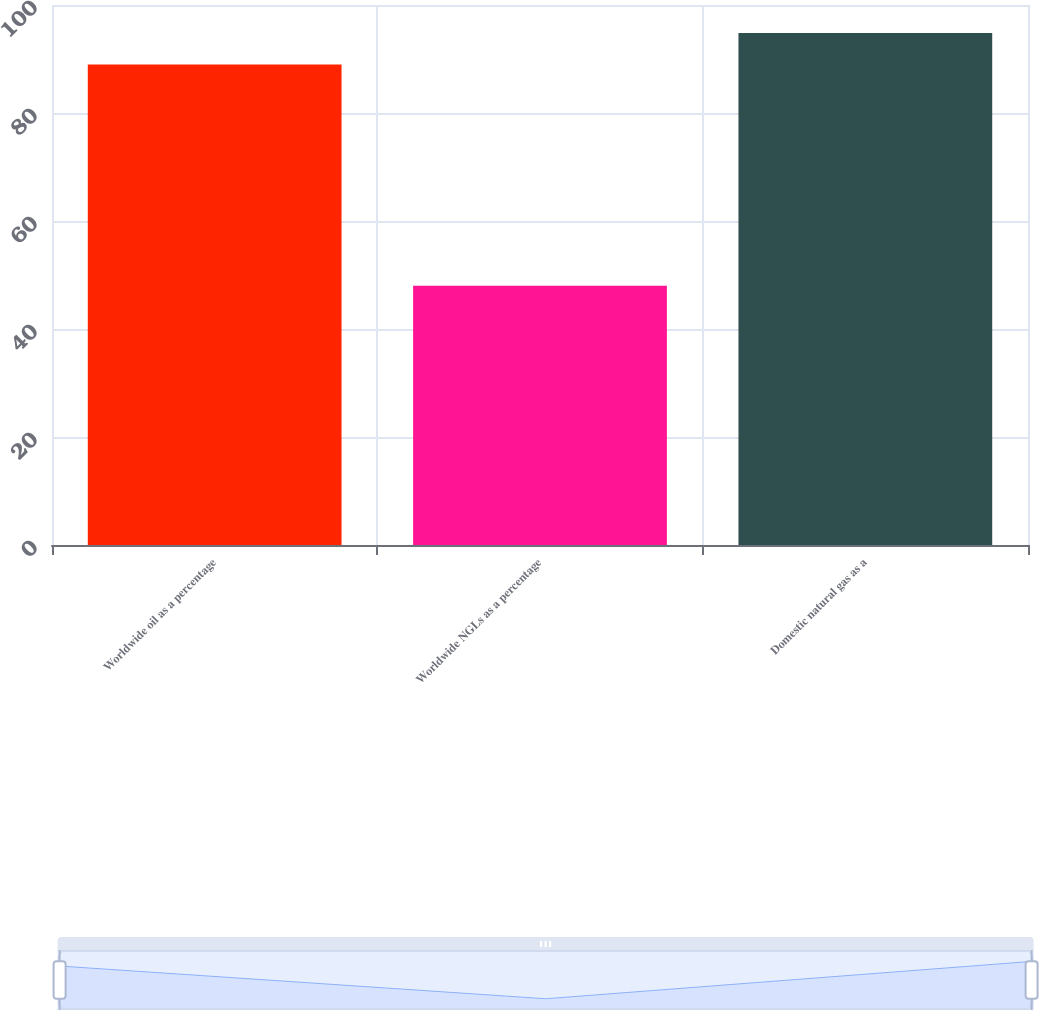Convert chart to OTSL. <chart><loc_0><loc_0><loc_500><loc_500><bar_chart><fcel>Worldwide oil as a percentage<fcel>Worldwide NGLs as a percentage<fcel>Domestic natural gas as a<nl><fcel>89<fcel>48<fcel>94.8<nl></chart> 